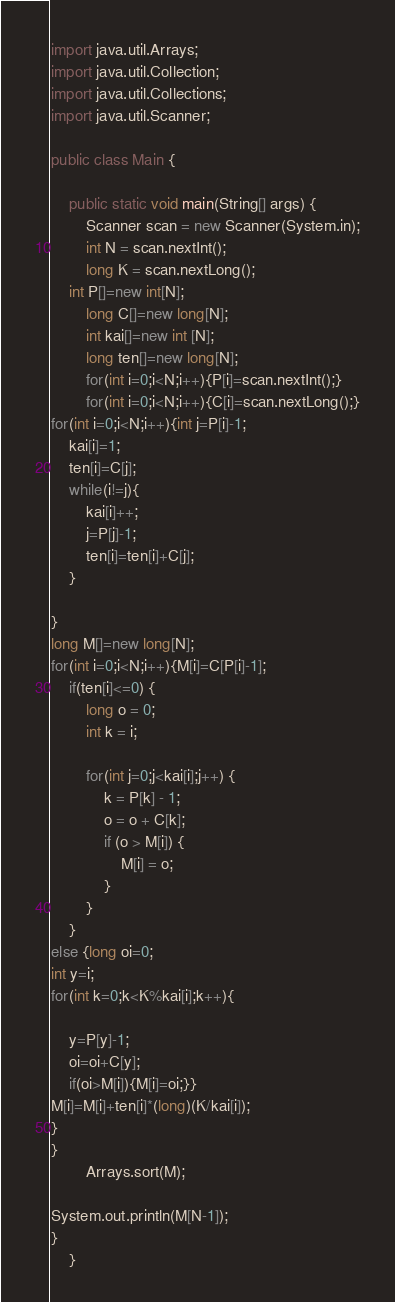<code> <loc_0><loc_0><loc_500><loc_500><_Java_>import java.util.Arrays;
import java.util.Collection;
import java.util.Collections;
import java.util.Scanner;

public class Main {

    public static void main(String[] args) {
        Scanner scan = new Scanner(System.in);
        int N = scan.nextInt();
        long K = scan.nextLong();
    int P[]=new int[N];
        long C[]=new long[N];
        int kai[]=new int [N];
        long ten[]=new long[N];
        for(int i=0;i<N;i++){P[i]=scan.nextInt();}
        for(int i=0;i<N;i++){C[i]=scan.nextLong();}
for(int i=0;i<N;i++){int j=P[i]-1;
    kai[i]=1;
    ten[i]=C[j];
    while(i!=j){
        kai[i]++;
        j=P[j]-1;
        ten[i]=ten[i]+C[j];
    }

}
long M[]=new long[N];
for(int i=0;i<N;i++){M[i]=C[P[i]-1];
    if(ten[i]<=0) {
        long o = 0;
        int k = i;

        for(int j=0;j<kai[i];j++) {
            k = P[k] - 1;
            o = o + C[k];
            if (o > M[i]) {
                M[i] = o;
            }
        }
    }
else {long oi=0;
int y=i;
for(int k=0;k<K%kai[i];k++){

    y=P[y]-1;
    oi=oi+C[y];
    if(oi>M[i]){M[i]=oi;}}
M[i]=M[i]+ten[i]*(long)(K/kai[i]);
}
}
        Arrays.sort(M);

System.out.println(M[N-1]);
}
    }

</code> 